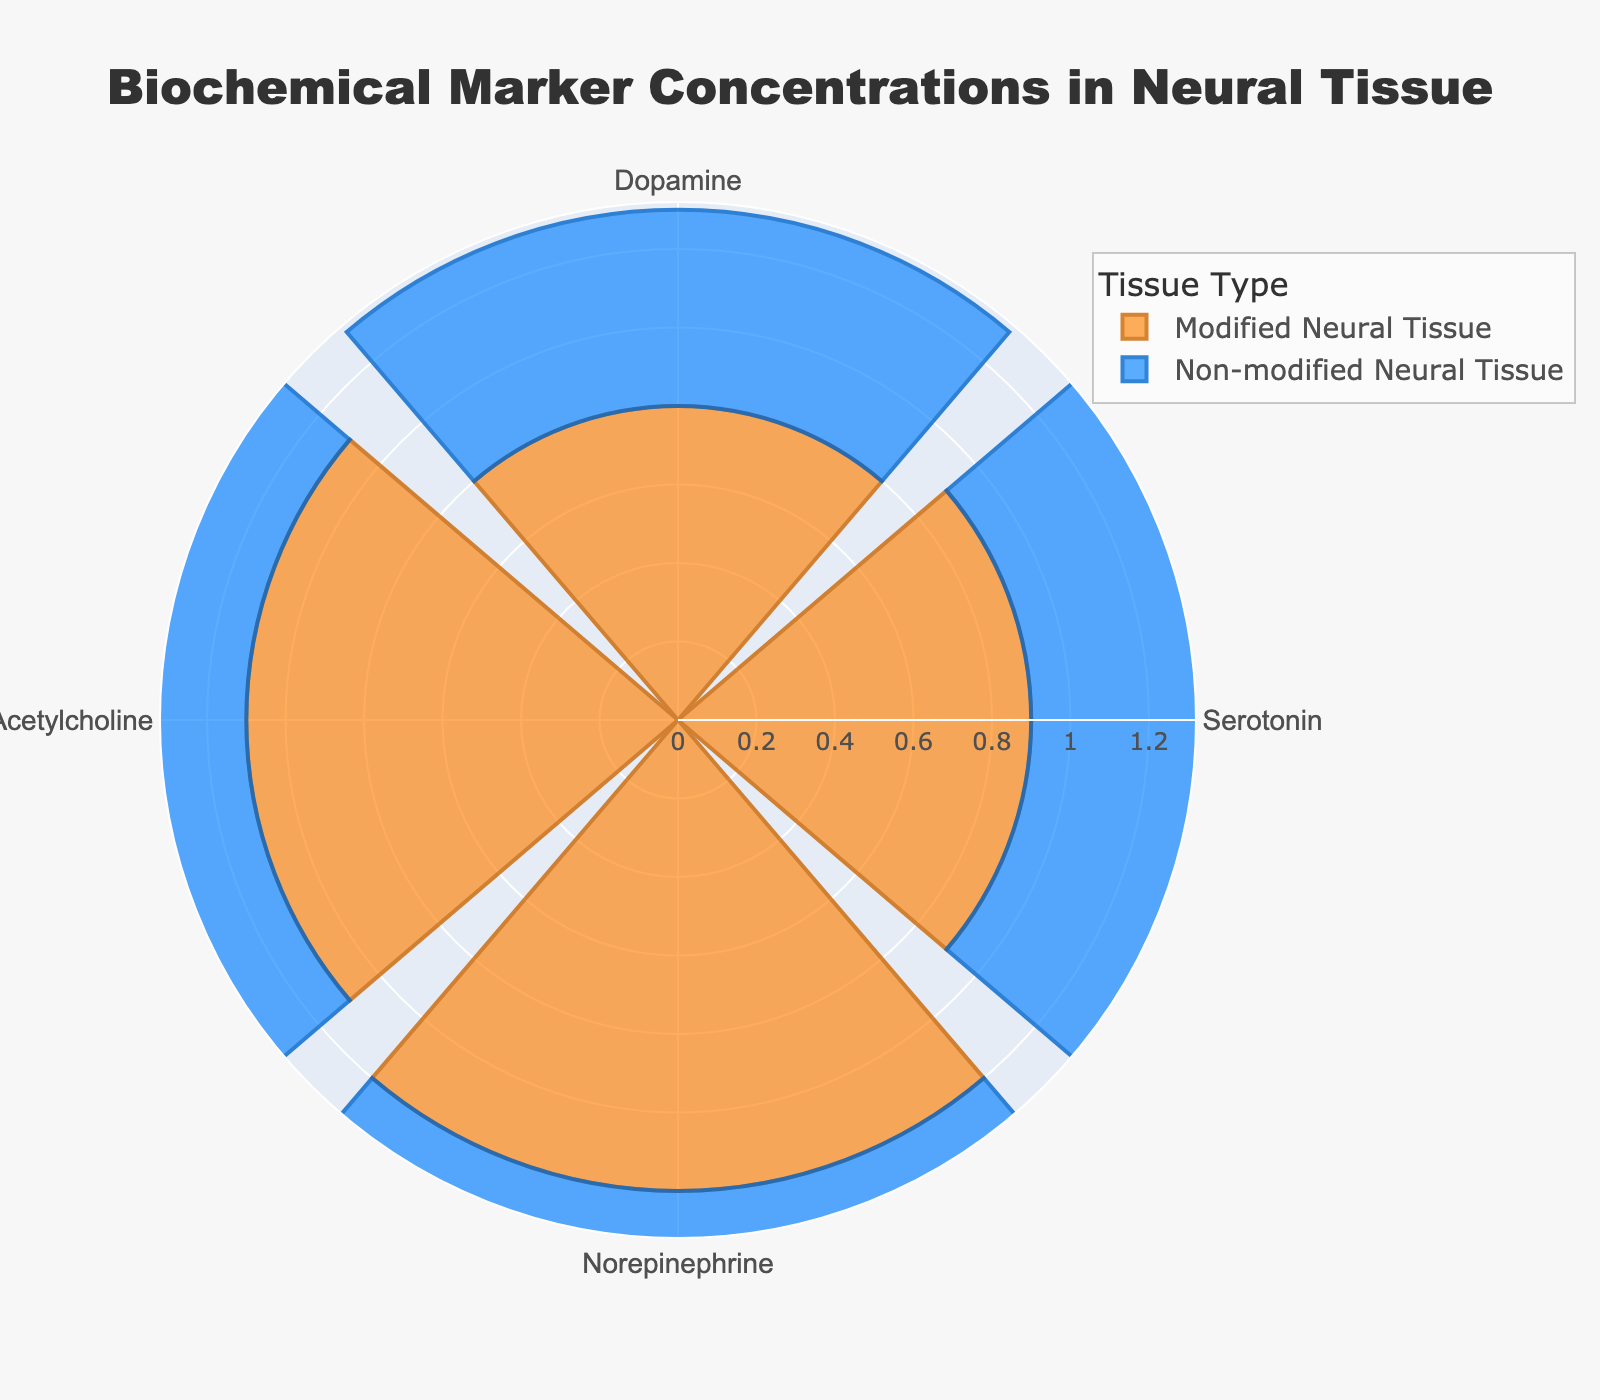What is the title of the figure? The title of the figure is usually at the top of the chart. By examining the visual cues, it reads "Biochemical Marker Concentrations in Neural Tissue".
Answer: Biochemical Marker Concentrations in Neural Tissue How many biochemical markers are represented in the chart? By counting the segments in the rose chart, you will see there are four distinct categories which match the biochemical markers listed in the data.
Answer: Four For which biochemical marker is the concentration difference between modified and non-modified neural tissue the greatest? To find this, subtract the concentration of each marker in the non-modified neural tissue from its concentration in the modified neural tissue. Acetylcholine: 1.1 - 0.7 = 0.4; Dopamine: 0.8 - 0.5 = 0.3; Norepinephrine: 1.2 - 0.8 = 0.4; Serotonin: 0.9 - 0.6 = 0.3. Both Acetylcholine and Norepinephrine show the greatest difference of 0.4.
Answer: Acetylcholine and Norepinephrine Which biochemical marker has the highest concentration in modified neural tissue? Examine the lengths of the bars corresponding to modified neural tissue. Norepinephrine has the longest bar with a value of 1.2 mol/L, indicating it has the highest concentration.
Answer: Norepinephrine Which biochemical marker shows the smallest increase in concentration in modified neural tissue compared to non-modified neural tissue? Compute the concentration differences: Dopamine: 0.8 - 0.5 = 0.3; Serotonin: 0.9 - 0.6 = 0.3; Norepinephrine: 1.2 - 0.8 = 0.4; Acetylcholine: 1.1 - 0.7 = 0.4. Both Dopamine and Serotonin show the smallest increase of 0.3.
Answer: Dopamine and Serotonin What range encompasses all the concentrations in the chart? The shortest bar (0.5 mol/L for Dopamine in non-modified neural tissue) and the longest bar (1.2 mol/L for Norepinephrine in modified neural tissue) give the range of concentrations.
Answer: 0.5 to 1.2 mol/L Which tissue type shows a higher average concentration across all biochemical markers, modified or non-modified neural tissue? Calculate the average concentration for both tissue types. Modified neural tissue: (0.8 + 0.9 + 1.2 + 1.1) / 4 = 1.0 mol/L. Non-modified neural tissue: (0.5 + 0.6 + 0.8 + 0.7) / 4 = 0.65 mol/L. Comparing 1.0 mol/L to 0.65 mol/L, the modified neural tissue has a higher average concentration.
Answer: Modified What is the ratio of Serotonin concentrations between modified and non-modified neural tissue? Divide the concentration of Serotonin in modified neural tissue by its concentration in non-modified neural tissue. 0.9 / 0.6 = 1.5
Answer: 1.5 Which biochemical marker has the closest concentrations between modified and non-modified neural tissue? Calculate the differences: Dopamine: 0.8 - 0.5 = 0.3; Serotonin: 0.9 - 0.6 = 0.3; Norepinephrine: 1.2 - 0.8 = 0.4; Acetylcholine: 1.1 - 0.7 = 0.4. Serotonin and Dopamine both have the smallest difference of 0.3, indicating they have the closest concentrations.
Answer: Serotonin and Dopamine 